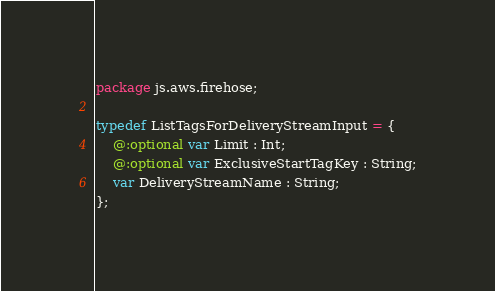<code> <loc_0><loc_0><loc_500><loc_500><_Haxe_>package js.aws.firehose;

typedef ListTagsForDeliveryStreamInput = {
    @:optional var Limit : Int;
    @:optional var ExclusiveStartTagKey : String;
    var DeliveryStreamName : String;
};
</code> 